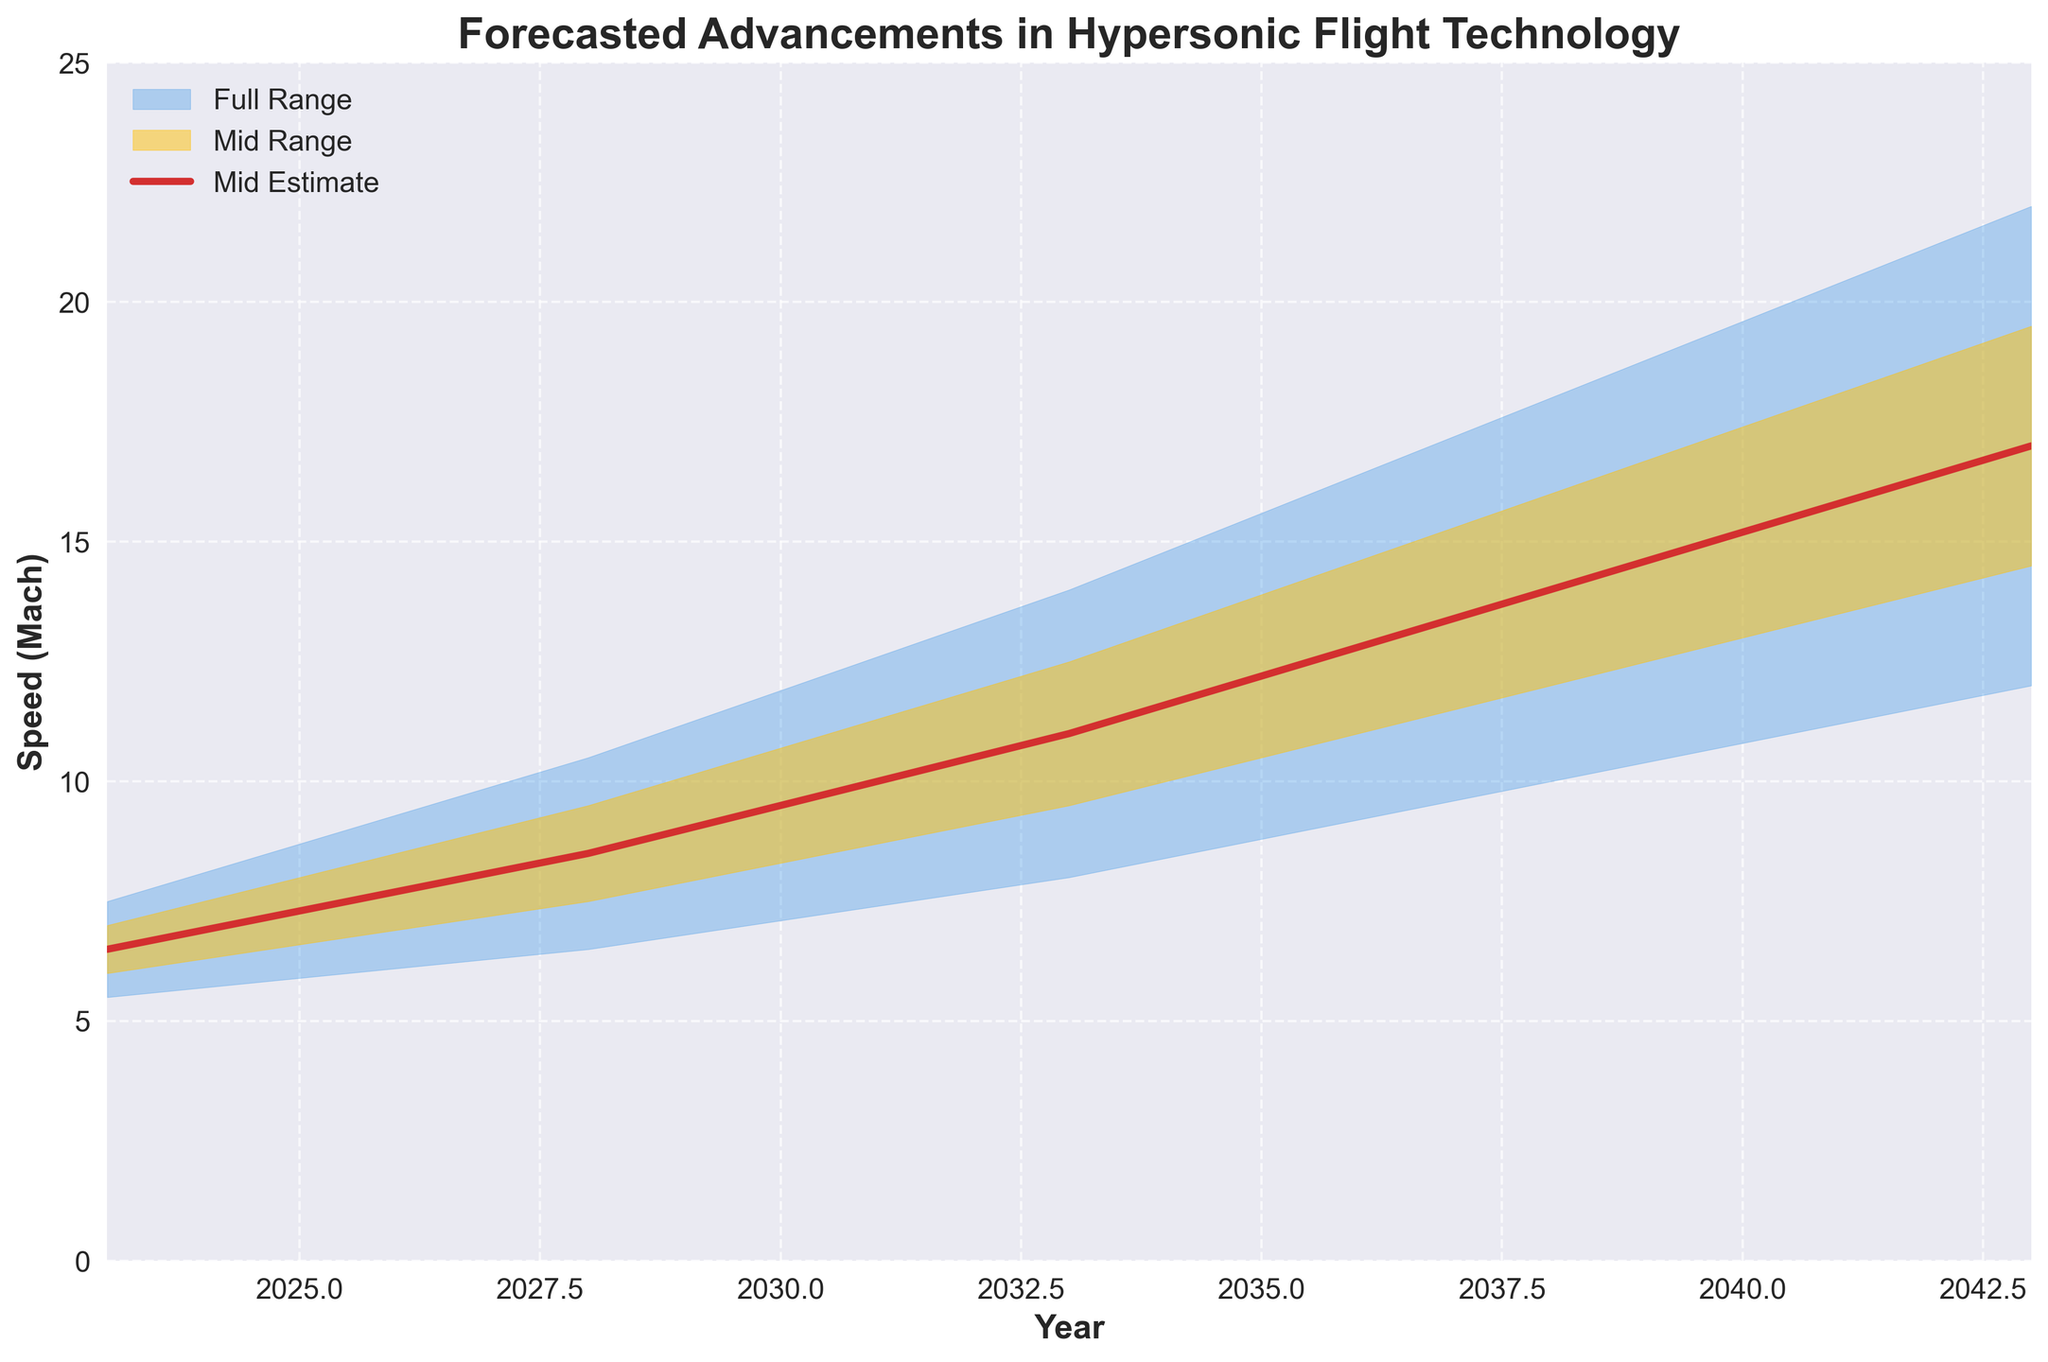What is the title of the plot? The title of the plot is usually located at the top of the figure. In this case, it clearly states: "Forecasted Advancements in Hypersonic Flight Technology".
Answer: Forecasted Advancements in Hypersonic Flight Technology What is the range of years displayed on the x-axis? By looking at the x-axis, you can see that the years span from 2023 to 2043.
Answer: 2023 to 2043 What is the estimated speed in Mach by the year 2033 according to the mid estimate? Locate the year 2033 on the x-axis and follow the line corresponding to the mid estimate. The plot shows it as 11.0 Mach.
Answer: 11.0 Mach What is the difference in the high estimates between the years 2023 and 2043? The high estimate at 2023 is 7.5 Mach and at 2043 it is 22.0 Mach. The difference is calculated by 22.0 - 7.5 = 14.5 Mach.
Answer: 14.5 Mach What is the color of the area representing the full range of estimates? The full range is represented by the shaded area between the low and high estimates. This area is filled with a light blue color.
Answer: Light blue Between which years does the high-mid estimate increase by 7 Mach? From the data, observe changes in the high-mid estimate. Between 2023 (7.0 Mach) and 2033 (12.5 Mach), the increase is 5.5 Mach, and between 2033 (12.5 Mach) and 2038 (16.0 Mach), the increase is 3.5 Mach. Actual increase by 7 Mach is between 2023 (7.0 Mach) and 2038 (14.0 Mach).
Answer: 2023 to 2038 By how much does the mid estimate grow from 2023 to 2043? The mid estimate for 2023 is 6.5 Mach and for 2043 it is 17.0 Mach. Hence, the growth is 17.0 - 6.5 = 10.5 Mach.
Answer: 10.5 Mach What is the speed range forecasted for 2038? In the plot data, for 2038, the low estimate is 10.0 Mach and the high estimate is 18.0 Mach, so the range is from 10.0 to 18.0 Mach.
Answer: 10.0 to 18.0 Mach Is the speed increase rate between 2023 and 2028 for high estimates slower or faster than between 2038 and 2043? Calculate the increase rate: from 2023 to 2028, the high estimate goes from 7.5 Mach to 10.5 Mach (increase of 3), and from 2038 to 2043 it goes from 18.0 Mach to 22.0 Mach (increase of 4). Therefore, the increase rate between 2038 and 2043 is faster.
Answer: Faster What bands of estimates span the highest increase by Mach value from 2023 to 2043? Compare the increases in the different bands: low estimate increases by 6.5 (12.0 - 5.5 = 6.5), low-mid estimate increases by 8.5, mid estimate increases by 10.5, high-mid estimate increases by 12.5, and high estimate increases by 14.5 Mach. Therefore, the high estimate spans the highest increase.
Answer: High Estimate 